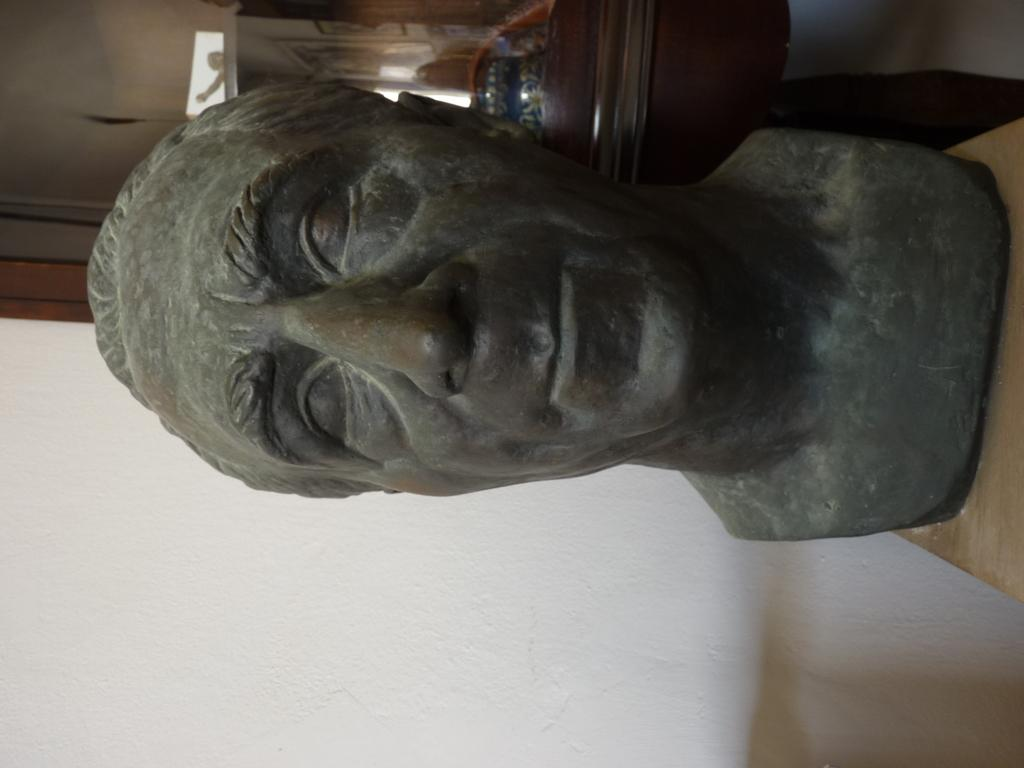What is the main subject of the image? There is a sculpture in the image. Where is the sculpture placed? The sculpture is on an object. What type of objects can be seen in the background of the image? There are wooden objects and other objects in the background of the image. What color is the surface at the bottom of the image? There is a white surface at the bottom of the image. What statement does the sculpture make about the brothers in the image? There are no brothers or statements present in the image; it only features a sculpture on an object and objects in the background. 